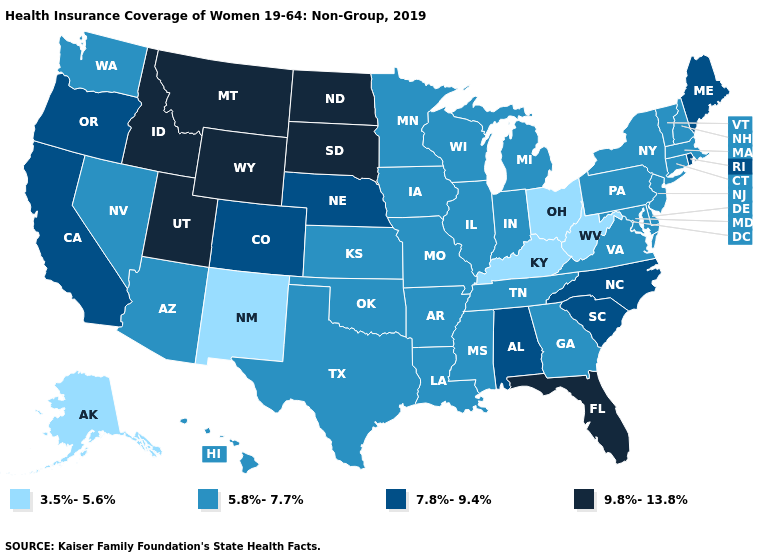What is the value of Wisconsin?
Write a very short answer. 5.8%-7.7%. Which states have the lowest value in the USA?
Write a very short answer. Alaska, Kentucky, New Mexico, Ohio, West Virginia. Does the first symbol in the legend represent the smallest category?
Give a very brief answer. Yes. Which states have the lowest value in the USA?
Give a very brief answer. Alaska, Kentucky, New Mexico, Ohio, West Virginia. Is the legend a continuous bar?
Answer briefly. No. Is the legend a continuous bar?
Concise answer only. No. Among the states that border New Mexico , does Utah have the highest value?
Keep it brief. Yes. What is the value of New Mexico?
Short answer required. 3.5%-5.6%. How many symbols are there in the legend?
Answer briefly. 4. Name the states that have a value in the range 3.5%-5.6%?
Keep it brief. Alaska, Kentucky, New Mexico, Ohio, West Virginia. Does the map have missing data?
Answer briefly. No. Among the states that border Iowa , which have the highest value?
Give a very brief answer. South Dakota. How many symbols are there in the legend?
Write a very short answer. 4. Among the states that border Oregon , which have the highest value?
Quick response, please. Idaho. Name the states that have a value in the range 5.8%-7.7%?
Concise answer only. Arizona, Arkansas, Connecticut, Delaware, Georgia, Hawaii, Illinois, Indiana, Iowa, Kansas, Louisiana, Maryland, Massachusetts, Michigan, Minnesota, Mississippi, Missouri, Nevada, New Hampshire, New Jersey, New York, Oklahoma, Pennsylvania, Tennessee, Texas, Vermont, Virginia, Washington, Wisconsin. 